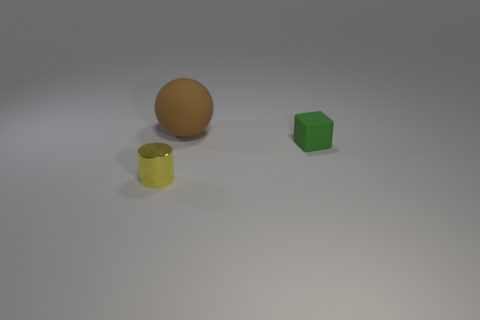There is a thing to the right of the brown ball on the left side of the green object; are there any large brown matte objects left of it? To the right of the brown ball, there is a yellow cylindrical object, and to the left of the green object, there does not appear to be any large brown matte objects. 